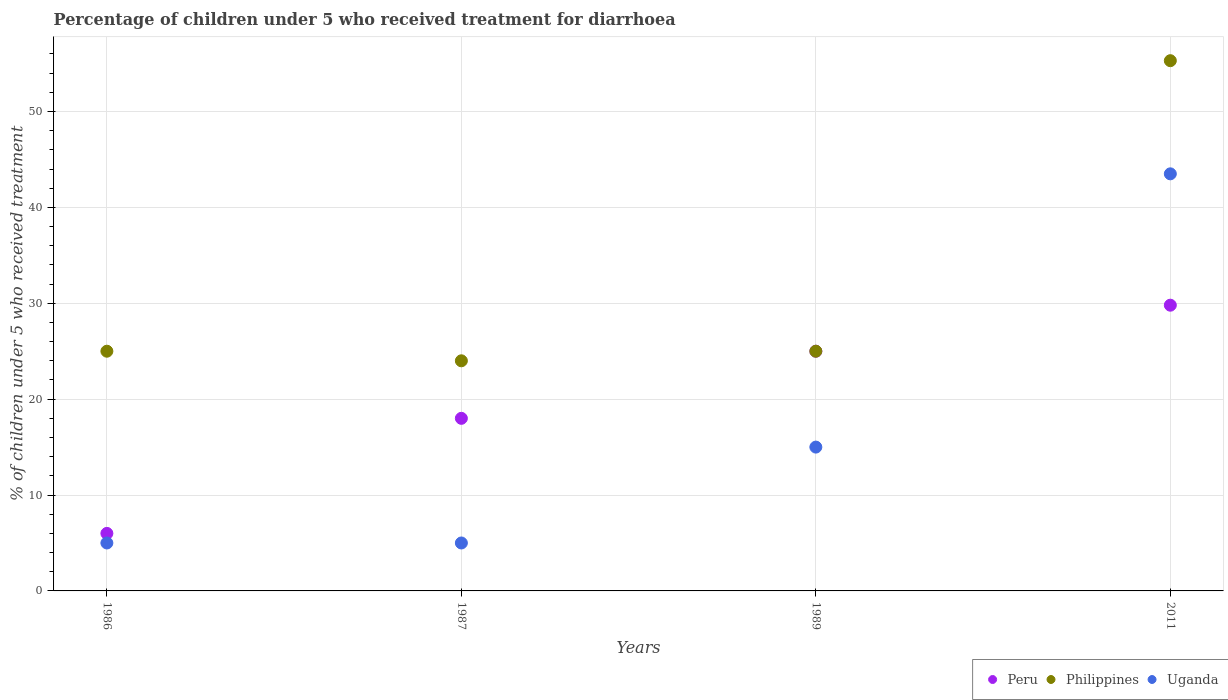How many different coloured dotlines are there?
Provide a succinct answer. 3. What is the percentage of children who received treatment for diarrhoea  in Peru in 1986?
Your answer should be compact. 6. Across all years, what is the maximum percentage of children who received treatment for diarrhoea  in Peru?
Your answer should be compact. 29.8. Across all years, what is the minimum percentage of children who received treatment for diarrhoea  in Philippines?
Offer a very short reply. 24. In which year was the percentage of children who received treatment for diarrhoea  in Philippines maximum?
Your answer should be very brief. 2011. In which year was the percentage of children who received treatment for diarrhoea  in Philippines minimum?
Make the answer very short. 1987. What is the total percentage of children who received treatment for diarrhoea  in Uganda in the graph?
Give a very brief answer. 68.5. What is the difference between the percentage of children who received treatment for diarrhoea  in Peru in 1989 and that in 2011?
Make the answer very short. -4.8. In the year 1986, what is the difference between the percentage of children who received treatment for diarrhoea  in Peru and percentage of children who received treatment for diarrhoea  in Uganda?
Your response must be concise. 1. What is the ratio of the percentage of children who received treatment for diarrhoea  in Peru in 1987 to that in 1989?
Ensure brevity in your answer.  0.72. Is the difference between the percentage of children who received treatment for diarrhoea  in Peru in 1986 and 1987 greater than the difference between the percentage of children who received treatment for diarrhoea  in Uganda in 1986 and 1987?
Make the answer very short. No. What is the difference between the highest and the second highest percentage of children who received treatment for diarrhoea  in Uganda?
Offer a terse response. 28.5. What is the difference between the highest and the lowest percentage of children who received treatment for diarrhoea  in Uganda?
Provide a short and direct response. 38.5. Does the percentage of children who received treatment for diarrhoea  in Peru monotonically increase over the years?
Offer a very short reply. Yes. Is the percentage of children who received treatment for diarrhoea  in Uganda strictly greater than the percentage of children who received treatment for diarrhoea  in Peru over the years?
Ensure brevity in your answer.  No. Is the percentage of children who received treatment for diarrhoea  in Peru strictly less than the percentage of children who received treatment for diarrhoea  in Uganda over the years?
Keep it short and to the point. No. How many years are there in the graph?
Make the answer very short. 4. Does the graph contain any zero values?
Give a very brief answer. No. Does the graph contain grids?
Give a very brief answer. Yes. Where does the legend appear in the graph?
Make the answer very short. Bottom right. How many legend labels are there?
Provide a short and direct response. 3. What is the title of the graph?
Ensure brevity in your answer.  Percentage of children under 5 who received treatment for diarrhoea. What is the label or title of the X-axis?
Keep it short and to the point. Years. What is the label or title of the Y-axis?
Ensure brevity in your answer.  % of children under 5 who received treatment. What is the % of children under 5 who received treatment in Peru in 1986?
Your response must be concise. 6. What is the % of children under 5 who received treatment in Philippines in 1986?
Keep it short and to the point. 25. What is the % of children under 5 who received treatment in Uganda in 1986?
Give a very brief answer. 5. What is the % of children under 5 who received treatment of Peru in 2011?
Your answer should be very brief. 29.8. What is the % of children under 5 who received treatment in Philippines in 2011?
Provide a short and direct response. 55.3. What is the % of children under 5 who received treatment of Uganda in 2011?
Provide a short and direct response. 43.5. Across all years, what is the maximum % of children under 5 who received treatment of Peru?
Make the answer very short. 29.8. Across all years, what is the maximum % of children under 5 who received treatment in Philippines?
Provide a succinct answer. 55.3. Across all years, what is the maximum % of children under 5 who received treatment in Uganda?
Your answer should be compact. 43.5. What is the total % of children under 5 who received treatment in Peru in the graph?
Keep it short and to the point. 78.8. What is the total % of children under 5 who received treatment of Philippines in the graph?
Provide a short and direct response. 129.3. What is the total % of children under 5 who received treatment in Uganda in the graph?
Keep it short and to the point. 68.5. What is the difference between the % of children under 5 who received treatment of Peru in 1986 and that in 1987?
Your answer should be very brief. -12. What is the difference between the % of children under 5 who received treatment of Philippines in 1986 and that in 1987?
Provide a succinct answer. 1. What is the difference between the % of children under 5 who received treatment of Peru in 1986 and that in 2011?
Offer a very short reply. -23.8. What is the difference between the % of children under 5 who received treatment in Philippines in 1986 and that in 2011?
Keep it short and to the point. -30.3. What is the difference between the % of children under 5 who received treatment in Uganda in 1986 and that in 2011?
Ensure brevity in your answer.  -38.5. What is the difference between the % of children under 5 who received treatment of Uganda in 1987 and that in 1989?
Provide a short and direct response. -10. What is the difference between the % of children under 5 who received treatment in Philippines in 1987 and that in 2011?
Your response must be concise. -31.3. What is the difference between the % of children under 5 who received treatment of Uganda in 1987 and that in 2011?
Provide a short and direct response. -38.5. What is the difference between the % of children under 5 who received treatment of Peru in 1989 and that in 2011?
Give a very brief answer. -4.8. What is the difference between the % of children under 5 who received treatment of Philippines in 1989 and that in 2011?
Offer a terse response. -30.3. What is the difference between the % of children under 5 who received treatment in Uganda in 1989 and that in 2011?
Offer a very short reply. -28.5. What is the difference between the % of children under 5 who received treatment in Peru in 1986 and the % of children under 5 who received treatment in Philippines in 1987?
Your answer should be very brief. -18. What is the difference between the % of children under 5 who received treatment of Philippines in 1986 and the % of children under 5 who received treatment of Uganda in 1989?
Your response must be concise. 10. What is the difference between the % of children under 5 who received treatment of Peru in 1986 and the % of children under 5 who received treatment of Philippines in 2011?
Provide a succinct answer. -49.3. What is the difference between the % of children under 5 who received treatment in Peru in 1986 and the % of children under 5 who received treatment in Uganda in 2011?
Offer a very short reply. -37.5. What is the difference between the % of children under 5 who received treatment of Philippines in 1986 and the % of children under 5 who received treatment of Uganda in 2011?
Provide a succinct answer. -18.5. What is the difference between the % of children under 5 who received treatment of Peru in 1987 and the % of children under 5 who received treatment of Uganda in 1989?
Ensure brevity in your answer.  3. What is the difference between the % of children under 5 who received treatment in Peru in 1987 and the % of children under 5 who received treatment in Philippines in 2011?
Provide a short and direct response. -37.3. What is the difference between the % of children under 5 who received treatment in Peru in 1987 and the % of children under 5 who received treatment in Uganda in 2011?
Your answer should be very brief. -25.5. What is the difference between the % of children under 5 who received treatment in Philippines in 1987 and the % of children under 5 who received treatment in Uganda in 2011?
Your answer should be compact. -19.5. What is the difference between the % of children under 5 who received treatment of Peru in 1989 and the % of children under 5 who received treatment of Philippines in 2011?
Your response must be concise. -30.3. What is the difference between the % of children under 5 who received treatment in Peru in 1989 and the % of children under 5 who received treatment in Uganda in 2011?
Provide a short and direct response. -18.5. What is the difference between the % of children under 5 who received treatment in Philippines in 1989 and the % of children under 5 who received treatment in Uganda in 2011?
Your response must be concise. -18.5. What is the average % of children under 5 who received treatment of Philippines per year?
Offer a very short reply. 32.33. What is the average % of children under 5 who received treatment of Uganda per year?
Your response must be concise. 17.12. In the year 1986, what is the difference between the % of children under 5 who received treatment of Peru and % of children under 5 who received treatment of Uganda?
Offer a terse response. 1. In the year 1987, what is the difference between the % of children under 5 who received treatment of Philippines and % of children under 5 who received treatment of Uganda?
Ensure brevity in your answer.  19. In the year 1989, what is the difference between the % of children under 5 who received treatment in Philippines and % of children under 5 who received treatment in Uganda?
Offer a terse response. 10. In the year 2011, what is the difference between the % of children under 5 who received treatment of Peru and % of children under 5 who received treatment of Philippines?
Your response must be concise. -25.5. In the year 2011, what is the difference between the % of children under 5 who received treatment in Peru and % of children under 5 who received treatment in Uganda?
Offer a very short reply. -13.7. What is the ratio of the % of children under 5 who received treatment of Philippines in 1986 to that in 1987?
Your response must be concise. 1.04. What is the ratio of the % of children under 5 who received treatment in Peru in 1986 to that in 1989?
Make the answer very short. 0.24. What is the ratio of the % of children under 5 who received treatment of Philippines in 1986 to that in 1989?
Provide a short and direct response. 1. What is the ratio of the % of children under 5 who received treatment in Uganda in 1986 to that in 1989?
Keep it short and to the point. 0.33. What is the ratio of the % of children under 5 who received treatment in Peru in 1986 to that in 2011?
Provide a succinct answer. 0.2. What is the ratio of the % of children under 5 who received treatment in Philippines in 1986 to that in 2011?
Provide a short and direct response. 0.45. What is the ratio of the % of children under 5 who received treatment in Uganda in 1986 to that in 2011?
Make the answer very short. 0.11. What is the ratio of the % of children under 5 who received treatment in Peru in 1987 to that in 1989?
Give a very brief answer. 0.72. What is the ratio of the % of children under 5 who received treatment of Peru in 1987 to that in 2011?
Ensure brevity in your answer.  0.6. What is the ratio of the % of children under 5 who received treatment of Philippines in 1987 to that in 2011?
Your answer should be very brief. 0.43. What is the ratio of the % of children under 5 who received treatment of Uganda in 1987 to that in 2011?
Keep it short and to the point. 0.11. What is the ratio of the % of children under 5 who received treatment in Peru in 1989 to that in 2011?
Your response must be concise. 0.84. What is the ratio of the % of children under 5 who received treatment in Philippines in 1989 to that in 2011?
Make the answer very short. 0.45. What is the ratio of the % of children under 5 who received treatment in Uganda in 1989 to that in 2011?
Keep it short and to the point. 0.34. What is the difference between the highest and the second highest % of children under 5 who received treatment of Peru?
Your answer should be compact. 4.8. What is the difference between the highest and the second highest % of children under 5 who received treatment in Philippines?
Your answer should be very brief. 30.3. What is the difference between the highest and the lowest % of children under 5 who received treatment in Peru?
Make the answer very short. 23.8. What is the difference between the highest and the lowest % of children under 5 who received treatment of Philippines?
Your response must be concise. 31.3. What is the difference between the highest and the lowest % of children under 5 who received treatment in Uganda?
Make the answer very short. 38.5. 